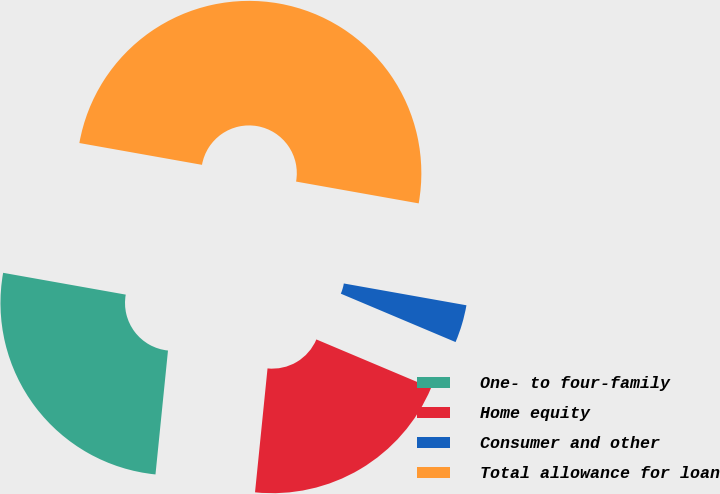<chart> <loc_0><loc_0><loc_500><loc_500><pie_chart><fcel>One- to four-family<fcel>Home equity<fcel>Consumer and other<fcel>Total allowance for loan<nl><fcel>26.2%<fcel>20.25%<fcel>3.55%<fcel>50.0%<nl></chart> 